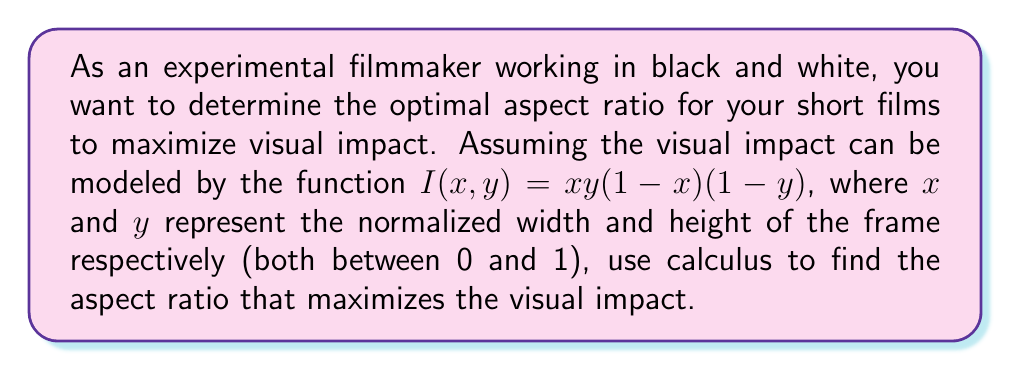Could you help me with this problem? To solve this problem, we'll use multivariable calculus:

1) First, we need to find the critical points of the function $I(x,y) = xy(1-x)(1-y)$.

2) To do this, we calculate the partial derivatives and set them equal to zero:

   $$\frac{\partial I}{\partial x} = y(1-y)(1-2x) = 0$$
   $$\frac{\partial I}{\partial y} = x(1-x)(1-2y) = 0$$

3) Solving these equations (ignoring the trivial solutions where $x$ or $y$ are 0 or 1):

   $1-2x = 0$, so $x = \frac{1}{2}$
   $1-2y = 0$, so $y = \frac{1}{2}$

4) The critical point is therefore $(\frac{1}{2}, \frac{1}{2})$.

5) To confirm this is a maximum, we can check the second derivatives:

   $$\frac{\partial^2 I}{\partial x^2} = -2y(1-y)$$
   $$\frac{\partial^2 I}{\partial y^2} = -2x(1-x)$$
   $$\frac{\partial^2 I}{\partial x \partial y} = (1-2x)(1-2y)$$

6) At the critical point $(\frac{1}{2}, \frac{1}{2})$:

   $$\frac{\partial^2 I}{\partial x^2} = -\frac{1}{2}$$
   $$\frac{\partial^2 I}{\partial y^2} = -\frac{1}{2}$$
   $$\frac{\partial^2 I}{\partial x \partial y} = 0$$

7) The Hessian matrix at this point is:

   $$H = \begin{bmatrix} 
   -\frac{1}{2} & 0 \\
   0 & -\frac{1}{2}
   \end{bmatrix}$$

   This is negative definite, confirming that $(\frac{1}{2}, \frac{1}{2})$ is indeed a maximum.

8) The optimal aspect ratio is therefore 1:1, or square.
Answer: The optimal aspect ratio for maximizing visual impact is 1:1 (square), corresponding to the point $(\frac{1}{2}, \frac{1}{2})$ in the normalized coordinate system. 